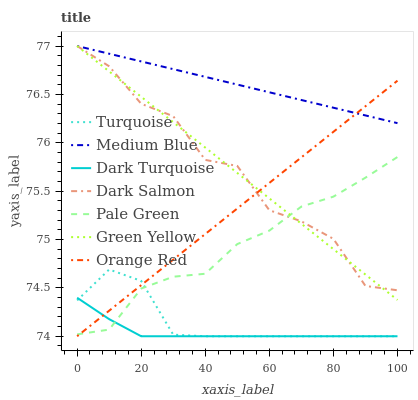Does Medium Blue have the minimum area under the curve?
Answer yes or no. No. Does Dark Turquoise have the maximum area under the curve?
Answer yes or no. No. Is Dark Turquoise the smoothest?
Answer yes or no. No. Is Dark Turquoise the roughest?
Answer yes or no. No. Does Medium Blue have the lowest value?
Answer yes or no. No. Does Dark Turquoise have the highest value?
Answer yes or no. No. Is Dark Turquoise less than Green Yellow?
Answer yes or no. Yes. Is Medium Blue greater than Turquoise?
Answer yes or no. Yes. Does Dark Turquoise intersect Green Yellow?
Answer yes or no. No. 